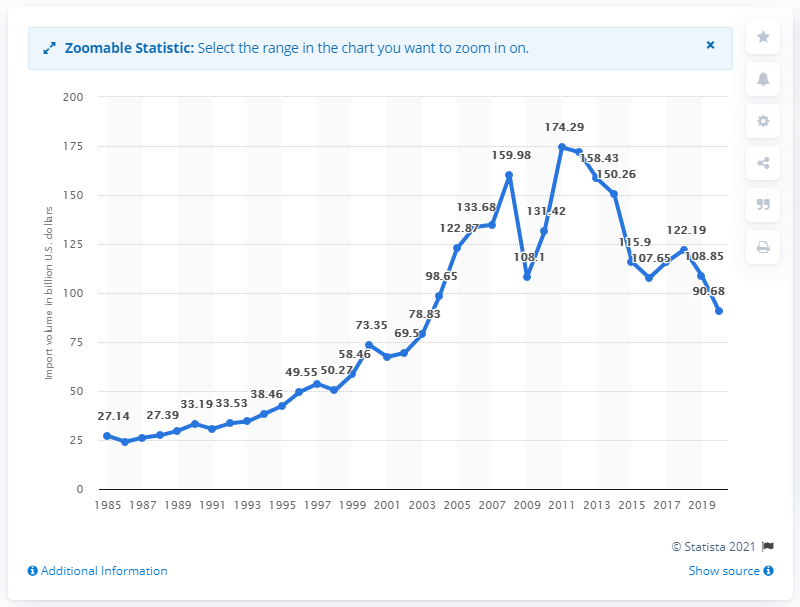Highlight a few significant elements in this photo. In 2020, the value of imports from South and Central America was 90.68 billion dollars. 